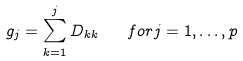<formula> <loc_0><loc_0><loc_500><loc_500>g _ { j } = \sum _ { k = 1 } ^ { j } D _ { k k } \quad { f o r } j = 1 , \dots , p</formula> 